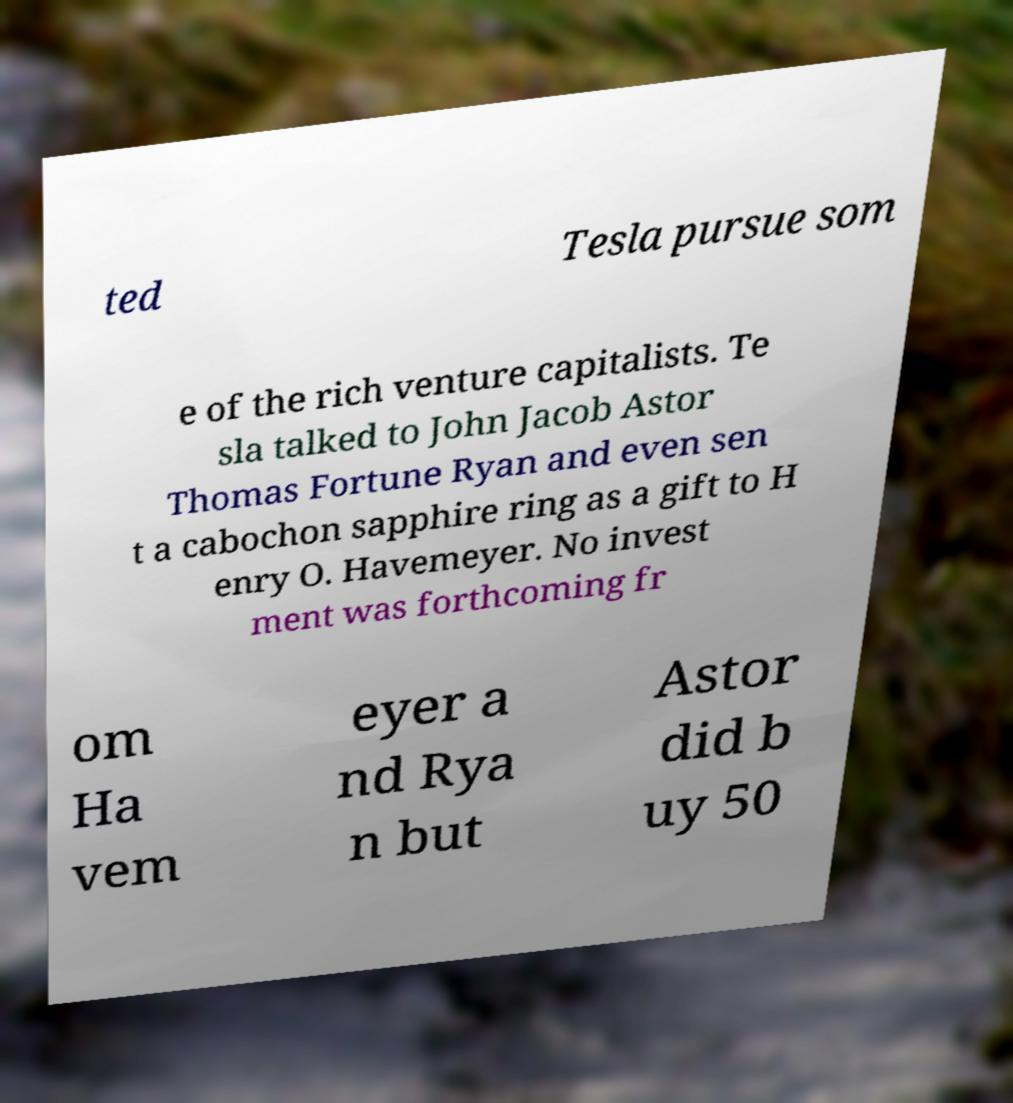Please read and relay the text visible in this image. What does it say? ted Tesla pursue som e of the rich venture capitalists. Te sla talked to John Jacob Astor Thomas Fortune Ryan and even sen t a cabochon sapphire ring as a gift to H enry O. Havemeyer. No invest ment was forthcoming fr om Ha vem eyer a nd Rya n but Astor did b uy 50 